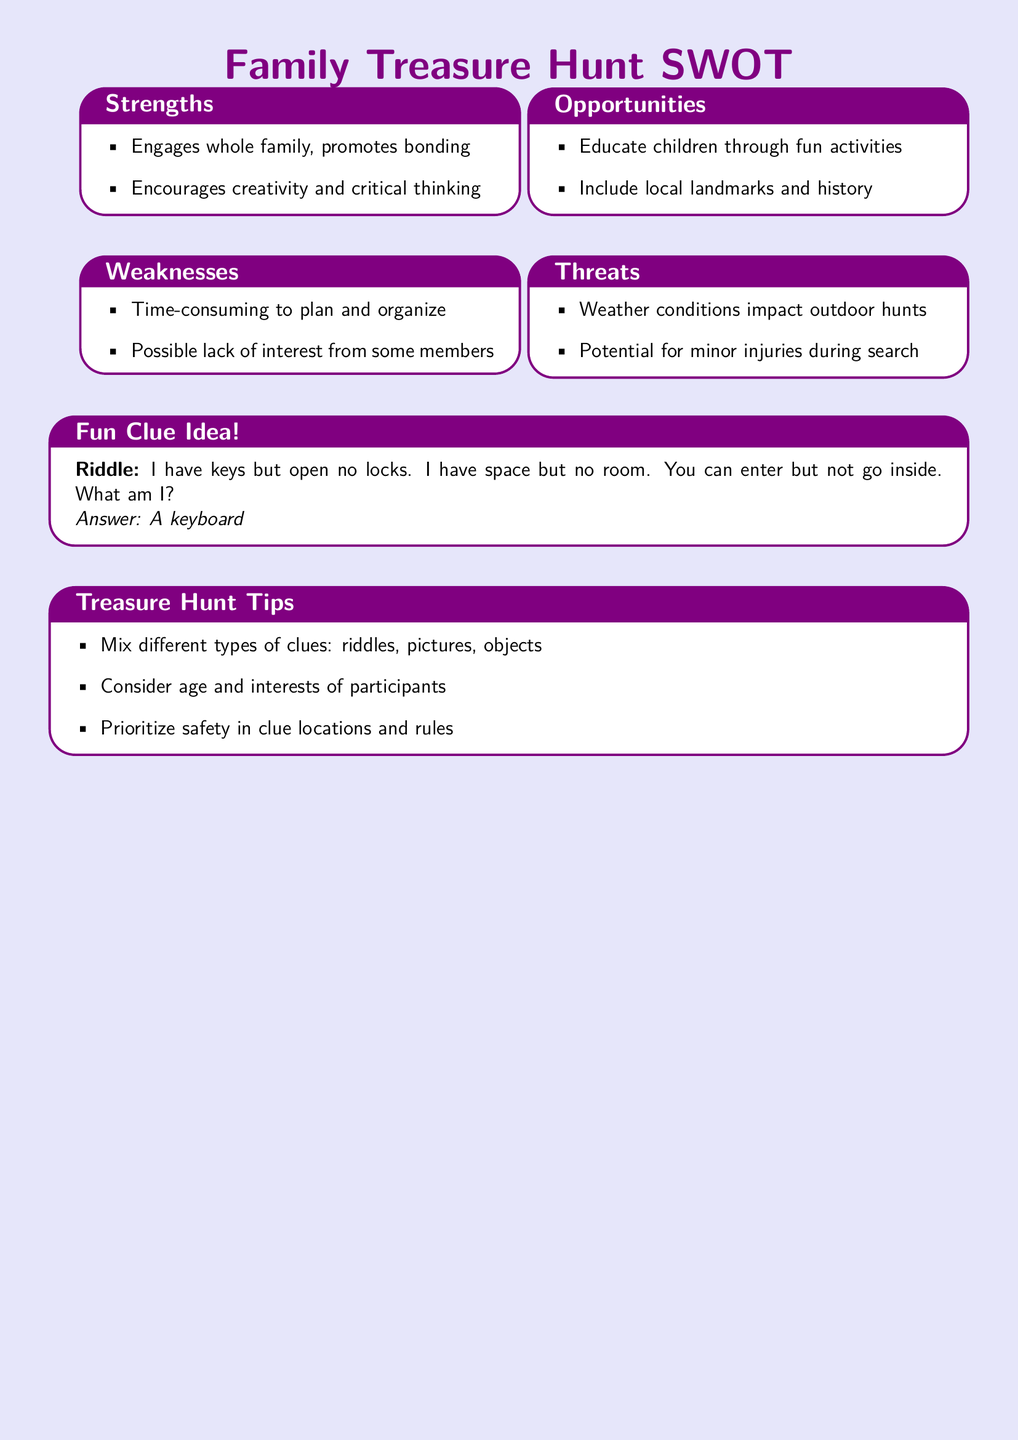what are two strengths of planning a family treasure hunt? The strengths are listed as engaging the whole family and encouraging creativity and critical thinking.
Answer: Engages whole family, promotes bonding; Encourages creativity and critical thinking what are two weaknesses of planning a family treasure hunt? The weaknesses include being time-consuming to plan and possible lack of interest from some members.
Answer: Time-consuming to plan and organize; Possible lack of interest from some members what is one opportunity in planning a family treasure hunt? The opportunities include educating children through fun activities and including local landmarks and history.
Answer: Educate children through fun activities what are two threats to consider when planning a family treasure hunt? The threats involve weather conditions impacting outdoor hunts and the potential for minor injuries during the search.
Answer: Weather conditions impact outdoor hunts; Potential for minor injuries during search what is the answer to the fun clue provided? The fun clue has a riddle with the answer that can be directly found in the document.
Answer: A keyboard how should the clues be mixed according to the treasure hunt tips? The treasure hunt tips suggest mixing different types of clues to make the activity more engaging.
Answer: Mix different types of clues: riddles, pictures, objects what safety aspect is mentioned in the treasure hunt tips? The document emphasizes prioritizing safety in clue locations and rules to avoid potential harm during the activity.
Answer: Prioritize safety in clue locations and rules how many SWOT sections are included in the document? The document has four sections titled Strengths, Weaknesses, Opportunities, and Threats, totaling four sections.
Answer: Four 